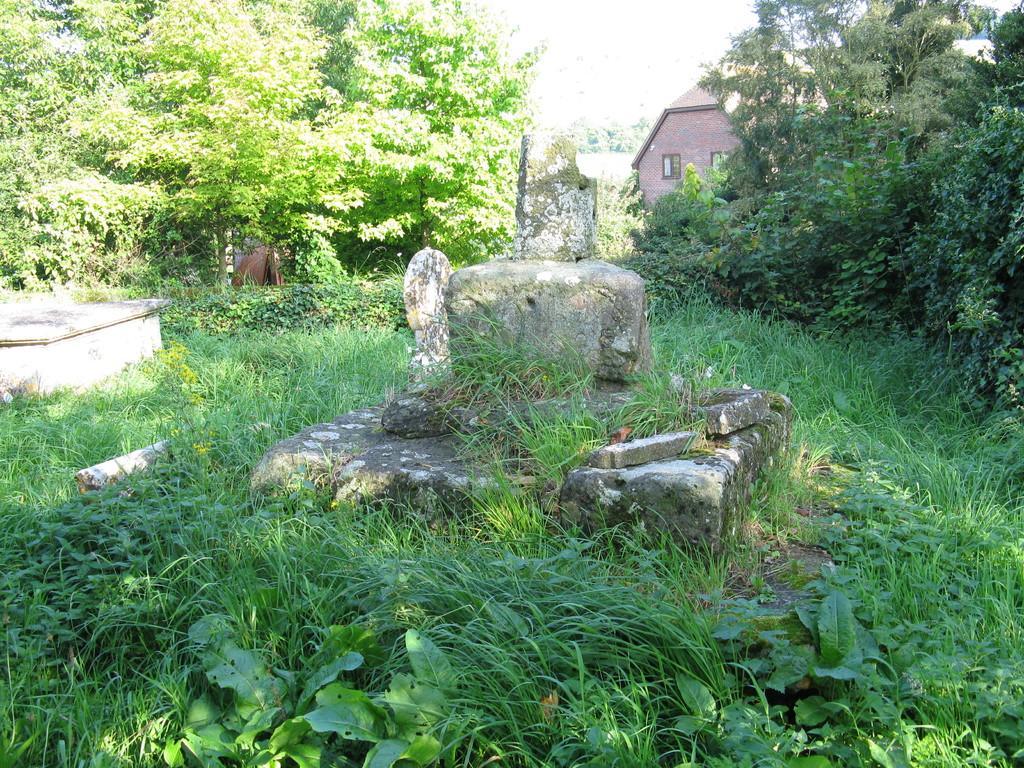In one or two sentences, can you explain what this image depicts? In the center of the image there are rocks. At the bottom we can see grass. In the background there are trees, shed and sky. 